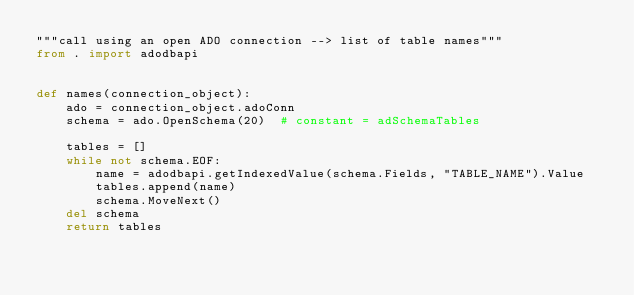Convert code to text. <code><loc_0><loc_0><loc_500><loc_500><_Python_>"""call using an open ADO connection --> list of table names"""
from . import adodbapi


def names(connection_object):
    ado = connection_object.adoConn
    schema = ado.OpenSchema(20)  # constant = adSchemaTables

    tables = []
    while not schema.EOF:
        name = adodbapi.getIndexedValue(schema.Fields, "TABLE_NAME").Value
        tables.append(name)
        schema.MoveNext()
    del schema
    return tables
</code> 